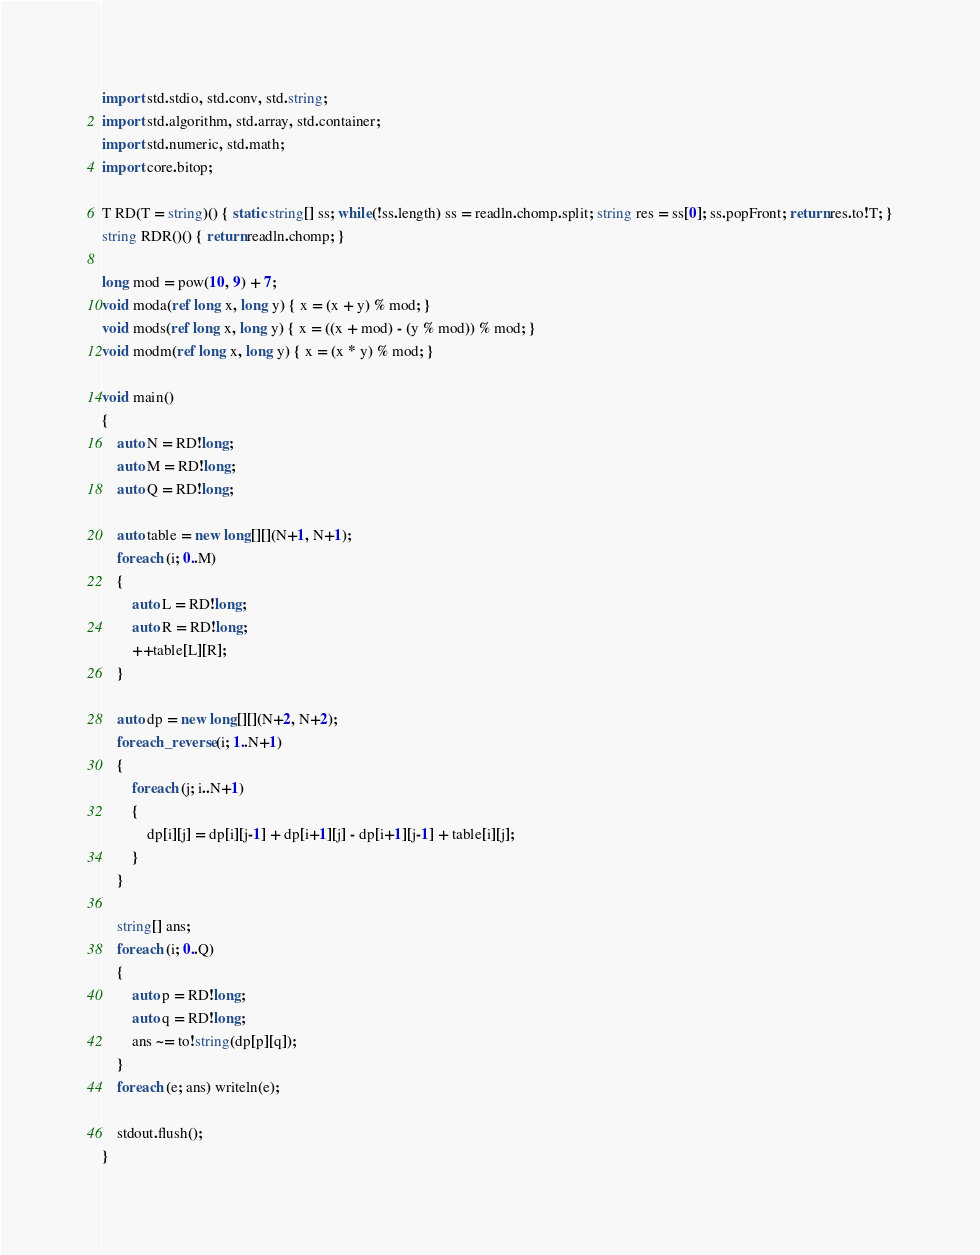Convert code to text. <code><loc_0><loc_0><loc_500><loc_500><_D_>import std.stdio, std.conv, std.string;
import std.algorithm, std.array, std.container;
import std.numeric, std.math;
import core.bitop;

T RD(T = string)() { static string[] ss; while(!ss.length) ss = readln.chomp.split; string res = ss[0]; ss.popFront; return res.to!T; }
string RDR()() { return readln.chomp; }

long mod = pow(10, 9) + 7;
void moda(ref long x, long y) { x = (x + y) % mod; }
void mods(ref long x, long y) { x = ((x + mod) - (y % mod)) % mod; }
void modm(ref long x, long y) { x = (x * y) % mod; }

void main()
{
	auto N = RD!long;
	auto M = RD!long;
	auto Q = RD!long;

	auto table = new long[][](N+1, N+1);
	foreach (i; 0..M)
	{
		auto L = RD!long;
		auto R = RD!long;
		++table[L][R];
	}

	auto dp = new long[][](N+2, N+2);
	foreach_reverse (i; 1..N+1)
	{
		foreach (j; i..N+1)
		{
			dp[i][j] = dp[i][j-1] + dp[i+1][j] - dp[i+1][j-1] + table[i][j];
		}
	}

	string[] ans;
	foreach (i; 0..Q)
	{
		auto p = RD!long;
		auto q = RD!long;
		ans ~= to!string(dp[p][q]);
	}
	foreach (e; ans) writeln(e);

	stdout.flush();
}</code> 